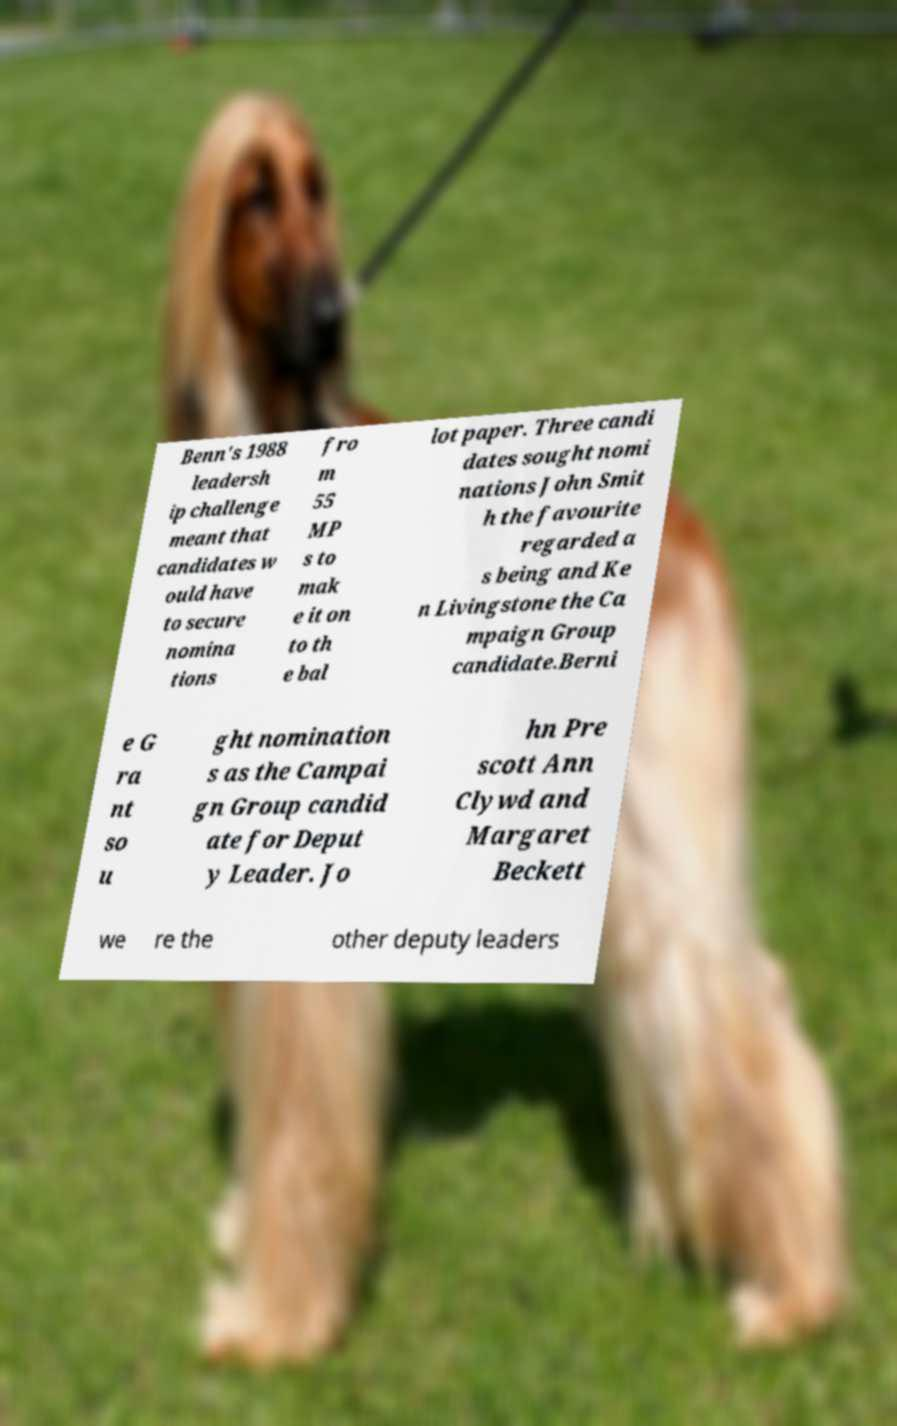Could you assist in decoding the text presented in this image and type it out clearly? Benn's 1988 leadersh ip challenge meant that candidates w ould have to secure nomina tions fro m 55 MP s to mak e it on to th e bal lot paper. Three candi dates sought nomi nations John Smit h the favourite regarded a s being and Ke n Livingstone the Ca mpaign Group candidate.Berni e G ra nt so u ght nomination s as the Campai gn Group candid ate for Deput y Leader. Jo hn Pre scott Ann Clywd and Margaret Beckett we re the other deputy leaders 